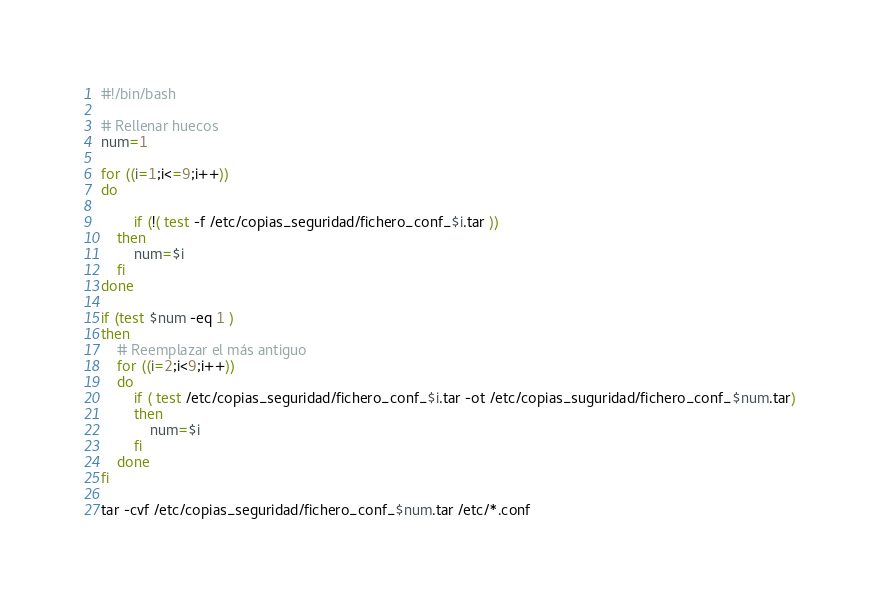Convert code to text. <code><loc_0><loc_0><loc_500><loc_500><_Bash_>#!/bin/bash

# Rellenar huecos
num=1

for ((i=1;i<=9;i++))
do

    	if (!( test -f /etc/copias_seguridad/fichero_conf_$i.tar ))
	then
	    num=$i
	fi
done

if (test $num -eq 1 )
then
    # Reemplazar el más antiguo
    for ((i=2;i<9;i++))
	do
	    if ( test /etc/copias_seguridad/fichero_conf_$i.tar -ot /etc/copias_suguridad/fichero_conf_$num.tar)
	    then
	        num=$i
	    fi
	done
fi

tar -cvf /etc/copias_seguridad/fichero_conf_$num.tar /etc/*.conf

</code> 